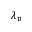<formula> <loc_0><loc_0><loc_500><loc_500>\lambda _ { p }</formula> 